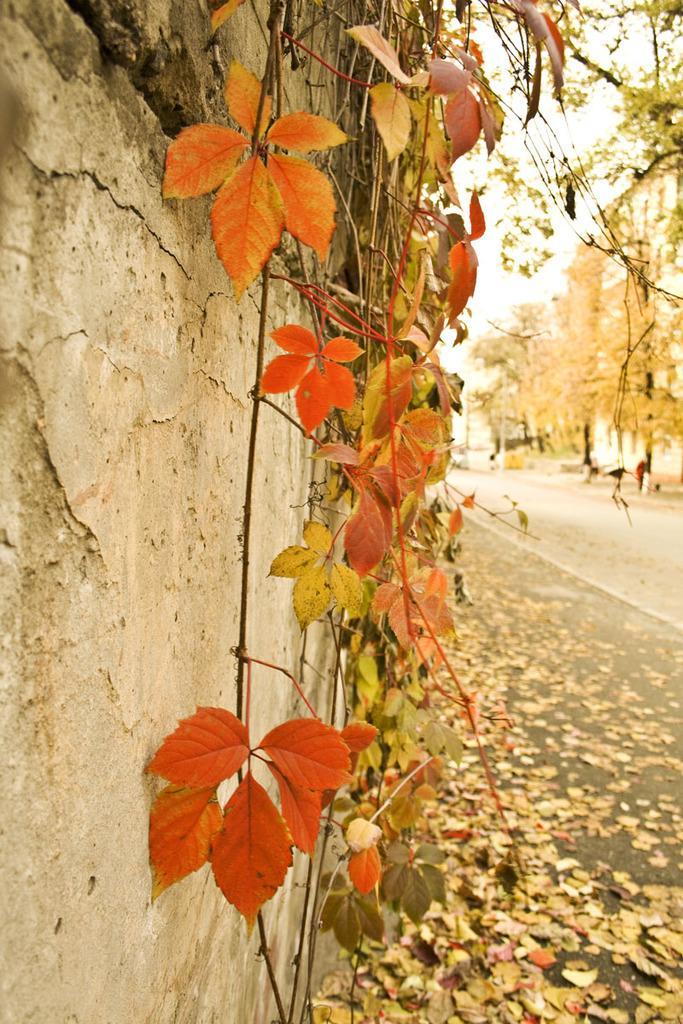Can you describe this image briefly? On the left side of the image I can see wall, leaves and branches. On the right side of the image there are trees and road. Above the road there are dried leaves. 